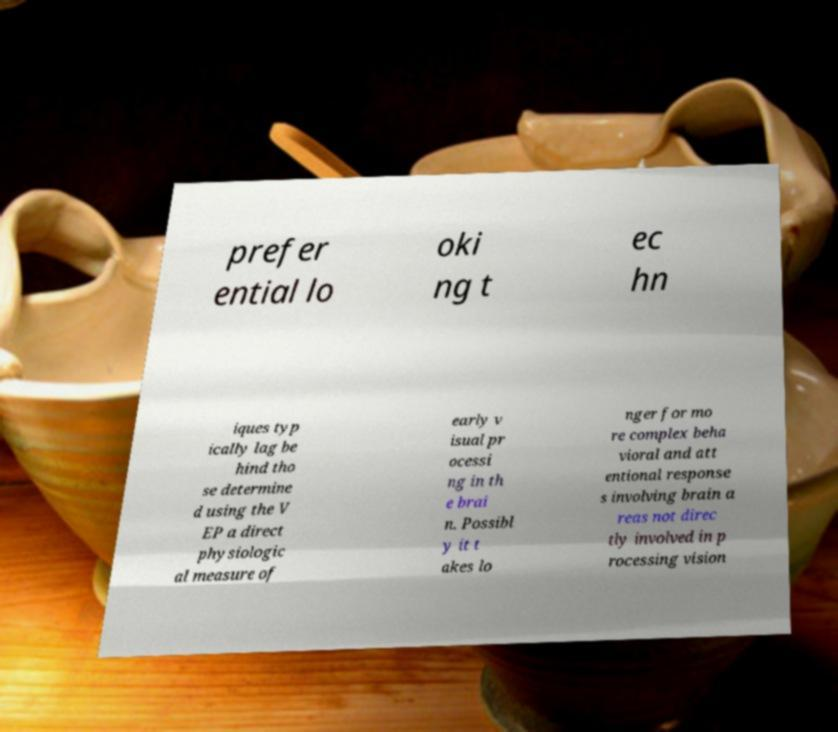For documentation purposes, I need the text within this image transcribed. Could you provide that? prefer ential lo oki ng t ec hn iques typ ically lag be hind tho se determine d using the V EP a direct physiologic al measure of early v isual pr ocessi ng in th e brai n. Possibl y it t akes lo nger for mo re complex beha vioral and att entional response s involving brain a reas not direc tly involved in p rocessing vision 